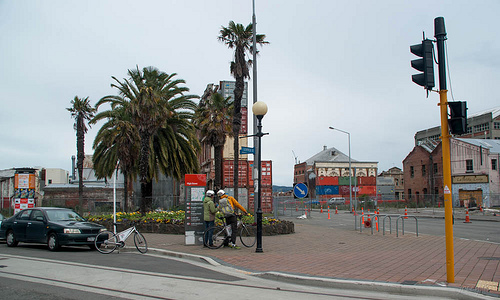<image>
Is the bicycle in front of the car? Yes. The bicycle is positioned in front of the car, appearing closer to the camera viewpoint. 